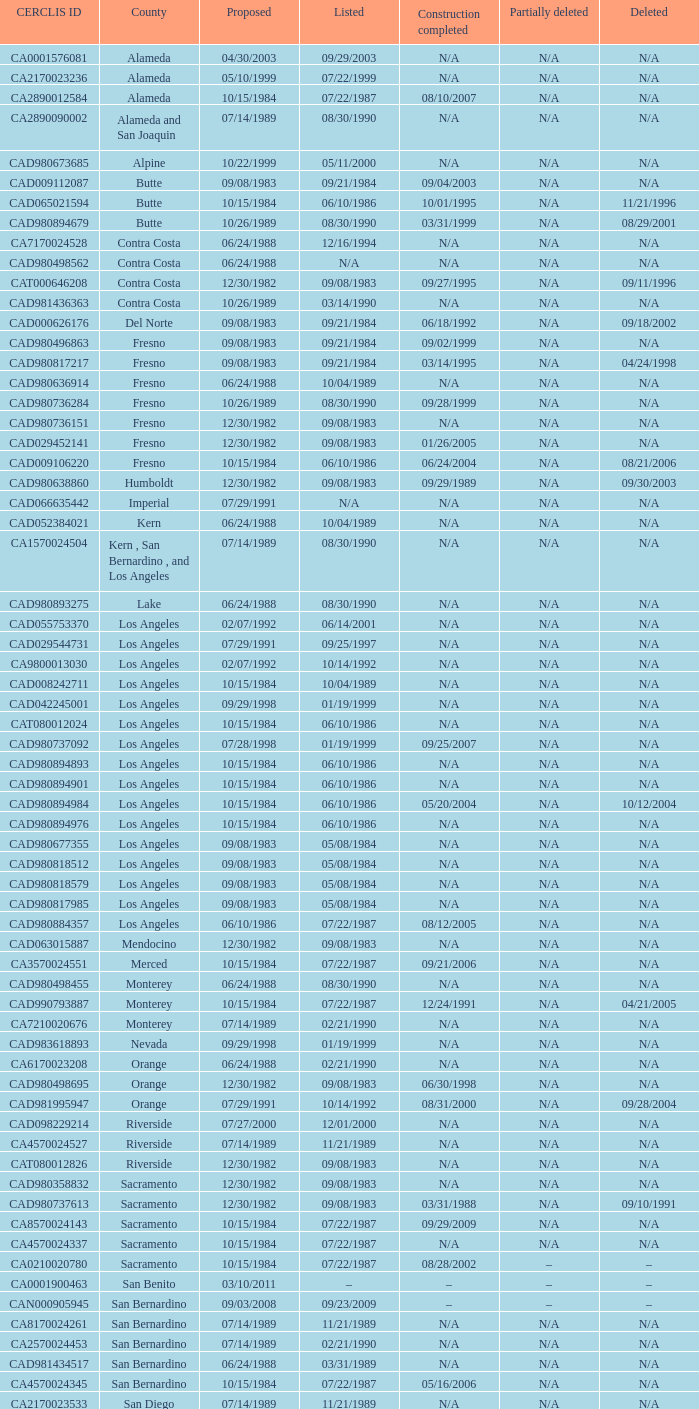What construction completed on 08/10/2007? 07/22/1987. 